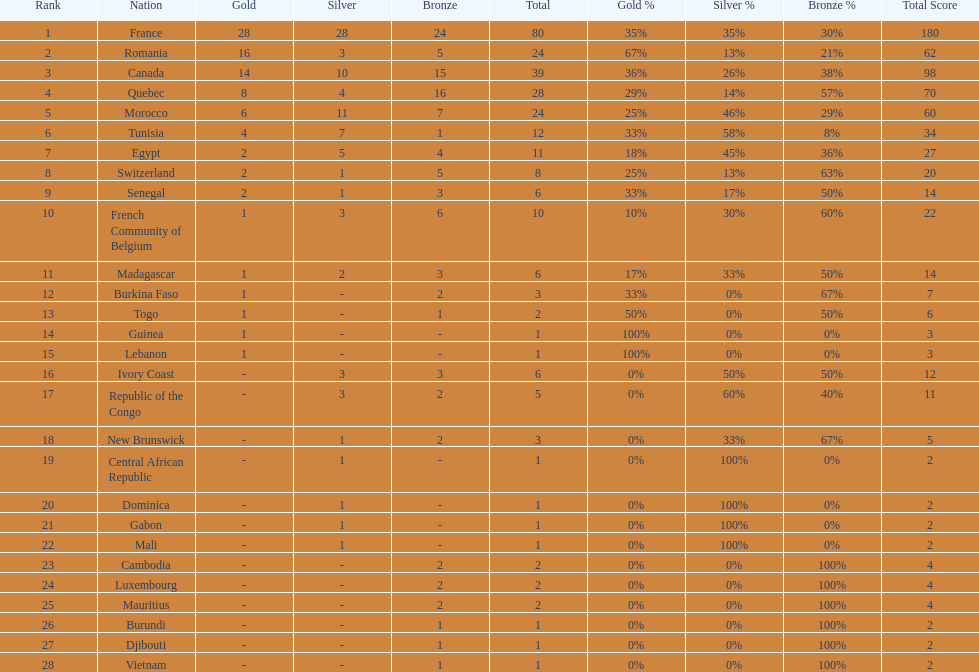How many counties have at least one silver medal? 18. 